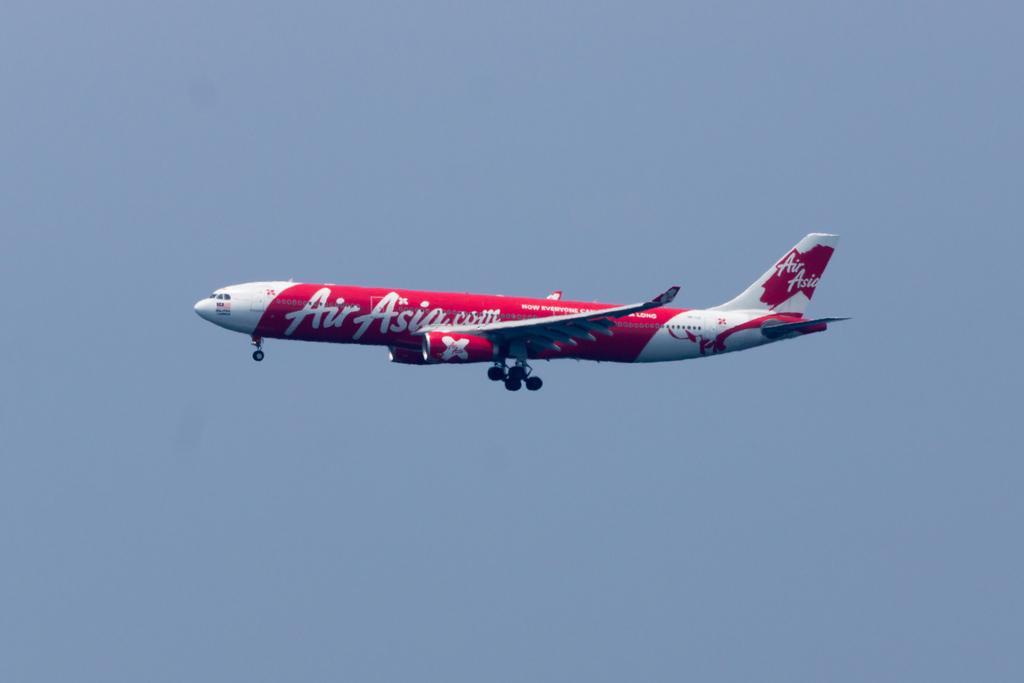Can you describe this image briefly? In the center of the image, we can see an aeroplane. In the background, there is sky. 